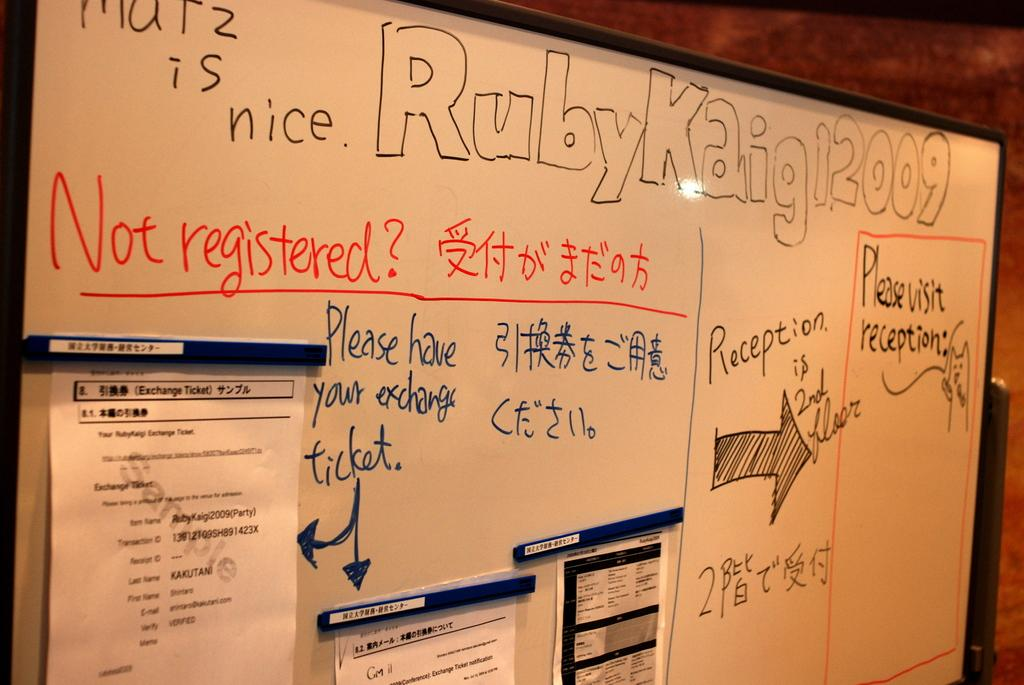<image>
Give a short and clear explanation of the subsequent image. A white board that reads "Ruby Kaigl, 2009" has an arrow pointing right. 